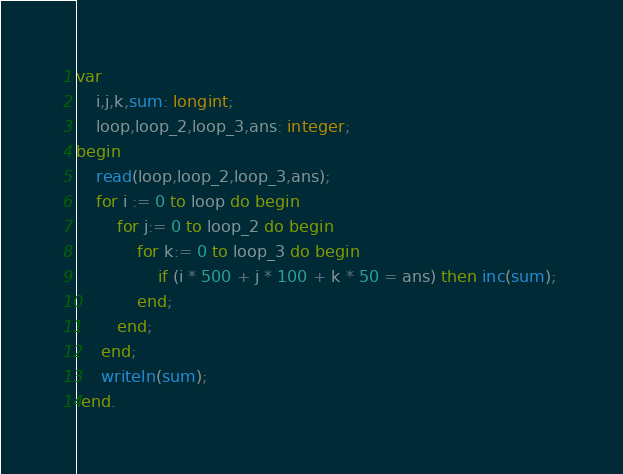Convert code to text. <code><loc_0><loc_0><loc_500><loc_500><_Pascal_>var 
	i,j,k,sum: longint;
    loop,loop_2,loop_3,ans: integer;
begin
	read(loop,loop_2,loop_3,ans);
	for i := 0 to loop do begin
        for j:= 0 to loop_2 do begin
            for k:= 0 to loop_3 do begin
               	if (i * 500 + j * 100 + k * 50 = ans) then inc(sum); 
            end;
        end; 
     end;
     writeln(sum);
 end.</code> 